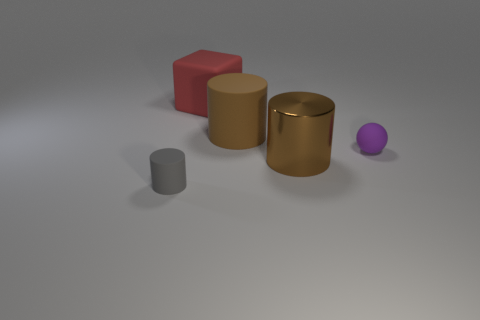Add 1 brown cylinders. How many objects exist? 6 Subtract all cylinders. How many objects are left? 2 Add 4 small green metal cylinders. How many small green metal cylinders exist? 4 Subtract 0 yellow balls. How many objects are left? 5 Subtract all large red spheres. Subtract all large brown rubber things. How many objects are left? 4 Add 4 rubber balls. How many rubber balls are left? 5 